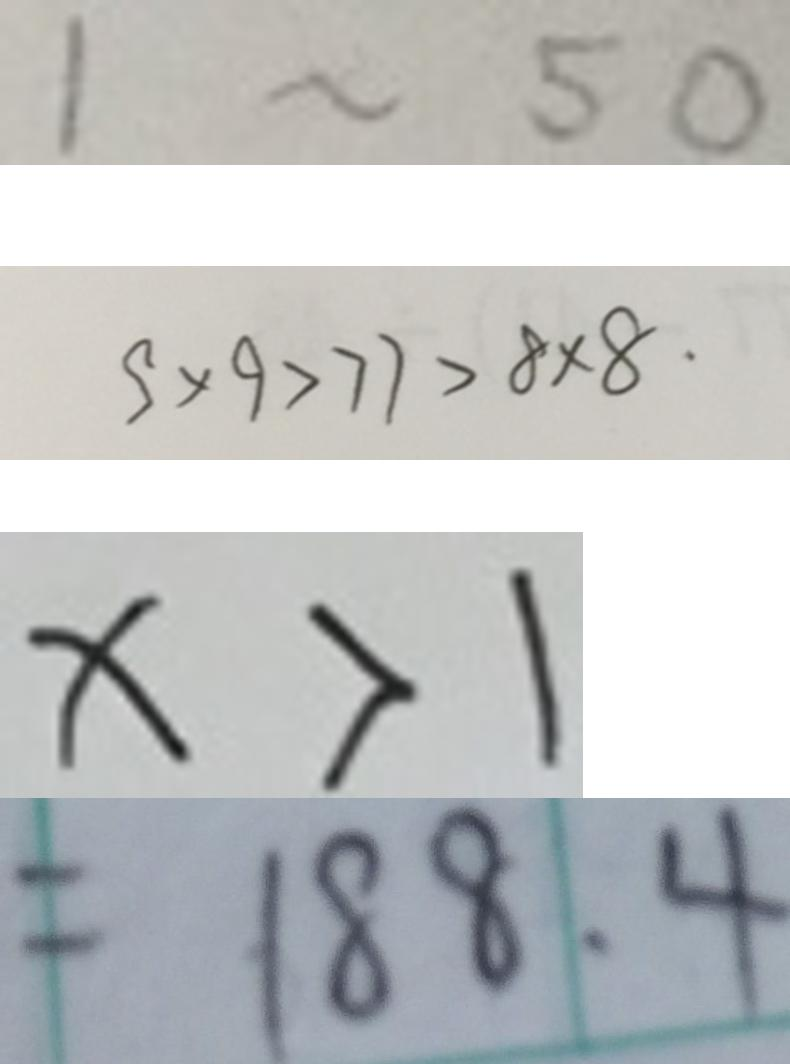<formula> <loc_0><loc_0><loc_500><loc_500>1 \sim 5 0 
 9 \times 9 > 7 7 > 8 \times 8 . 
 x > 1 
 = 1 8 8 . 4</formula> 